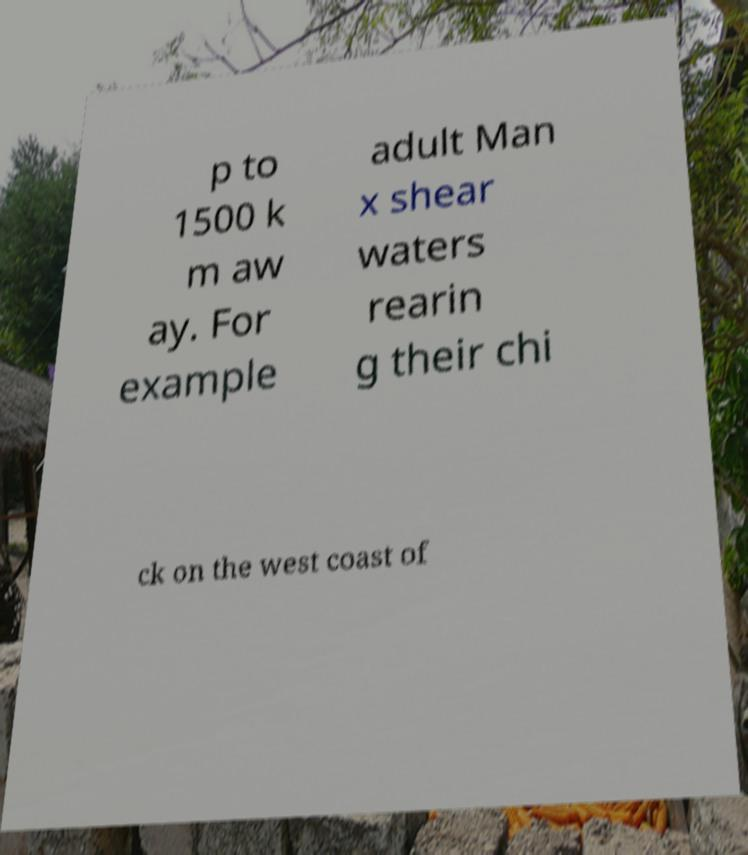Could you assist in decoding the text presented in this image and type it out clearly? p to 1500 k m aw ay. For example adult Man x shear waters rearin g their chi ck on the west coast of 